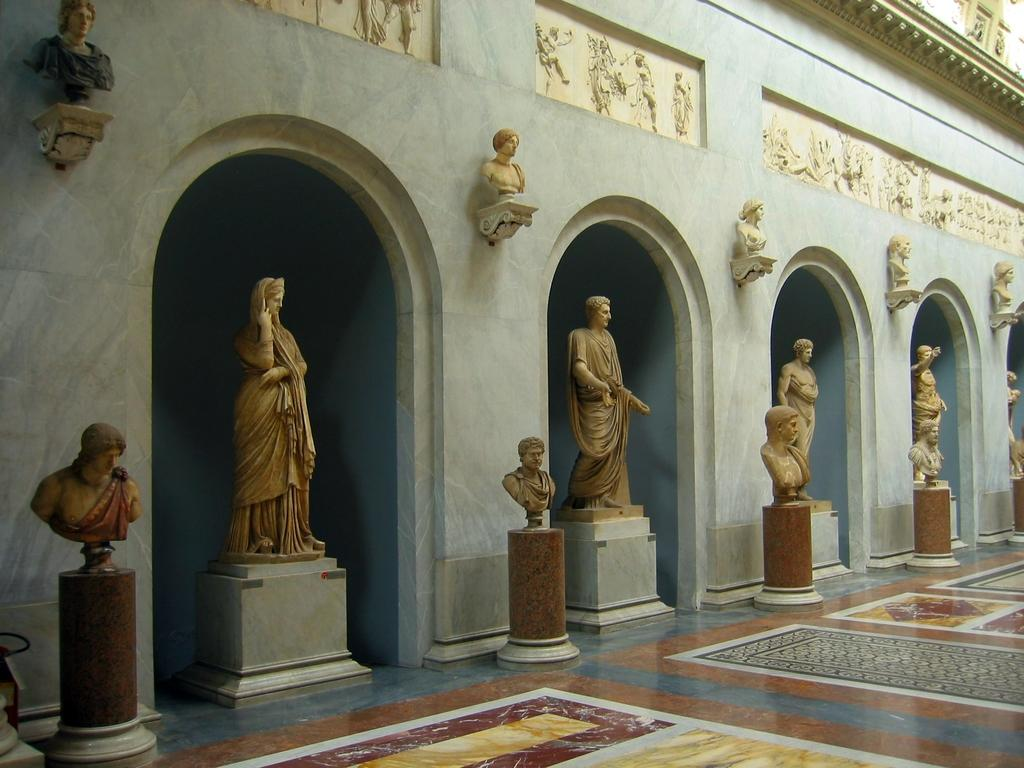What type of artwork can be seen in the image? There are statues and sculptures in the image. Where are the statues and sculptures located? The statues and sculptures are on the wall. Is there a stream of oatmeal flowing down the wall in the image? No, there is no stream of oatmeal or any other liquid visible in the image. The image only features statues and sculptures on the wall. 